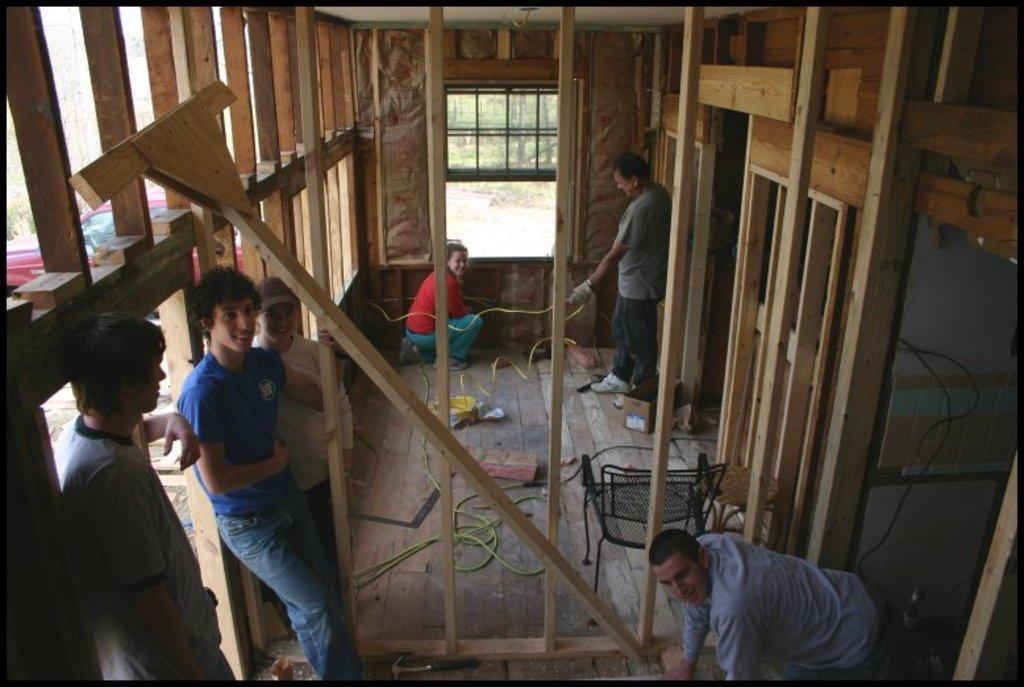Could you give a brief overview of what you see in this image? In the image few people are standing and sitting and smiling and there are some wires and there is a chair. They are in a wooden building and there is a window. Through the window we can see some trees and there is a vehicle. 